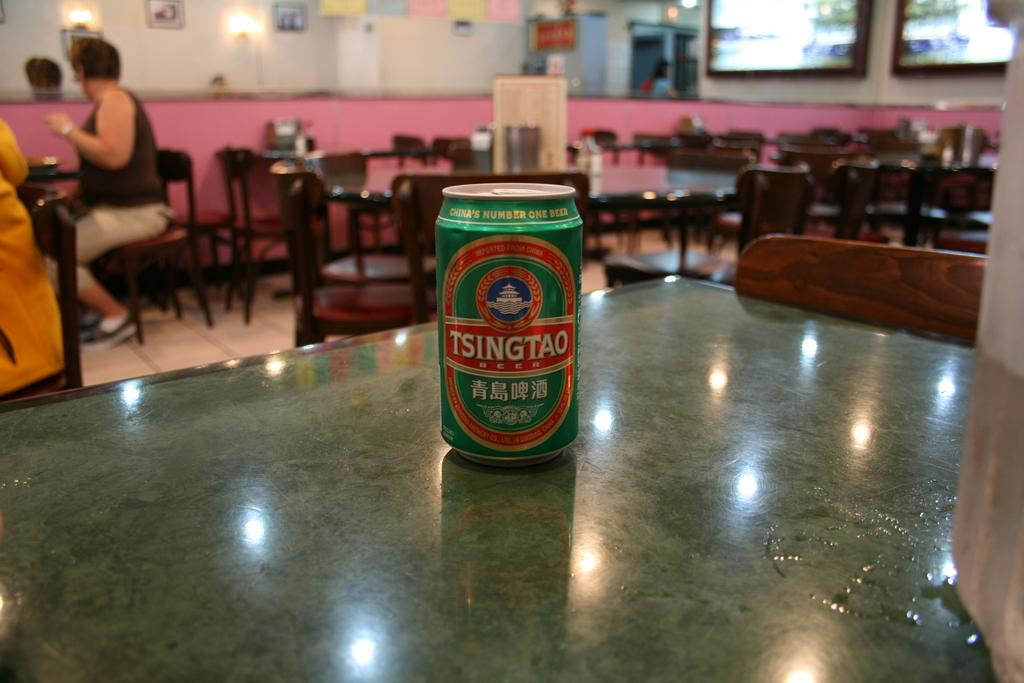<image>
Present a compact description of the photo's key features. Green beer can with the word TSINGTAO on the front. 